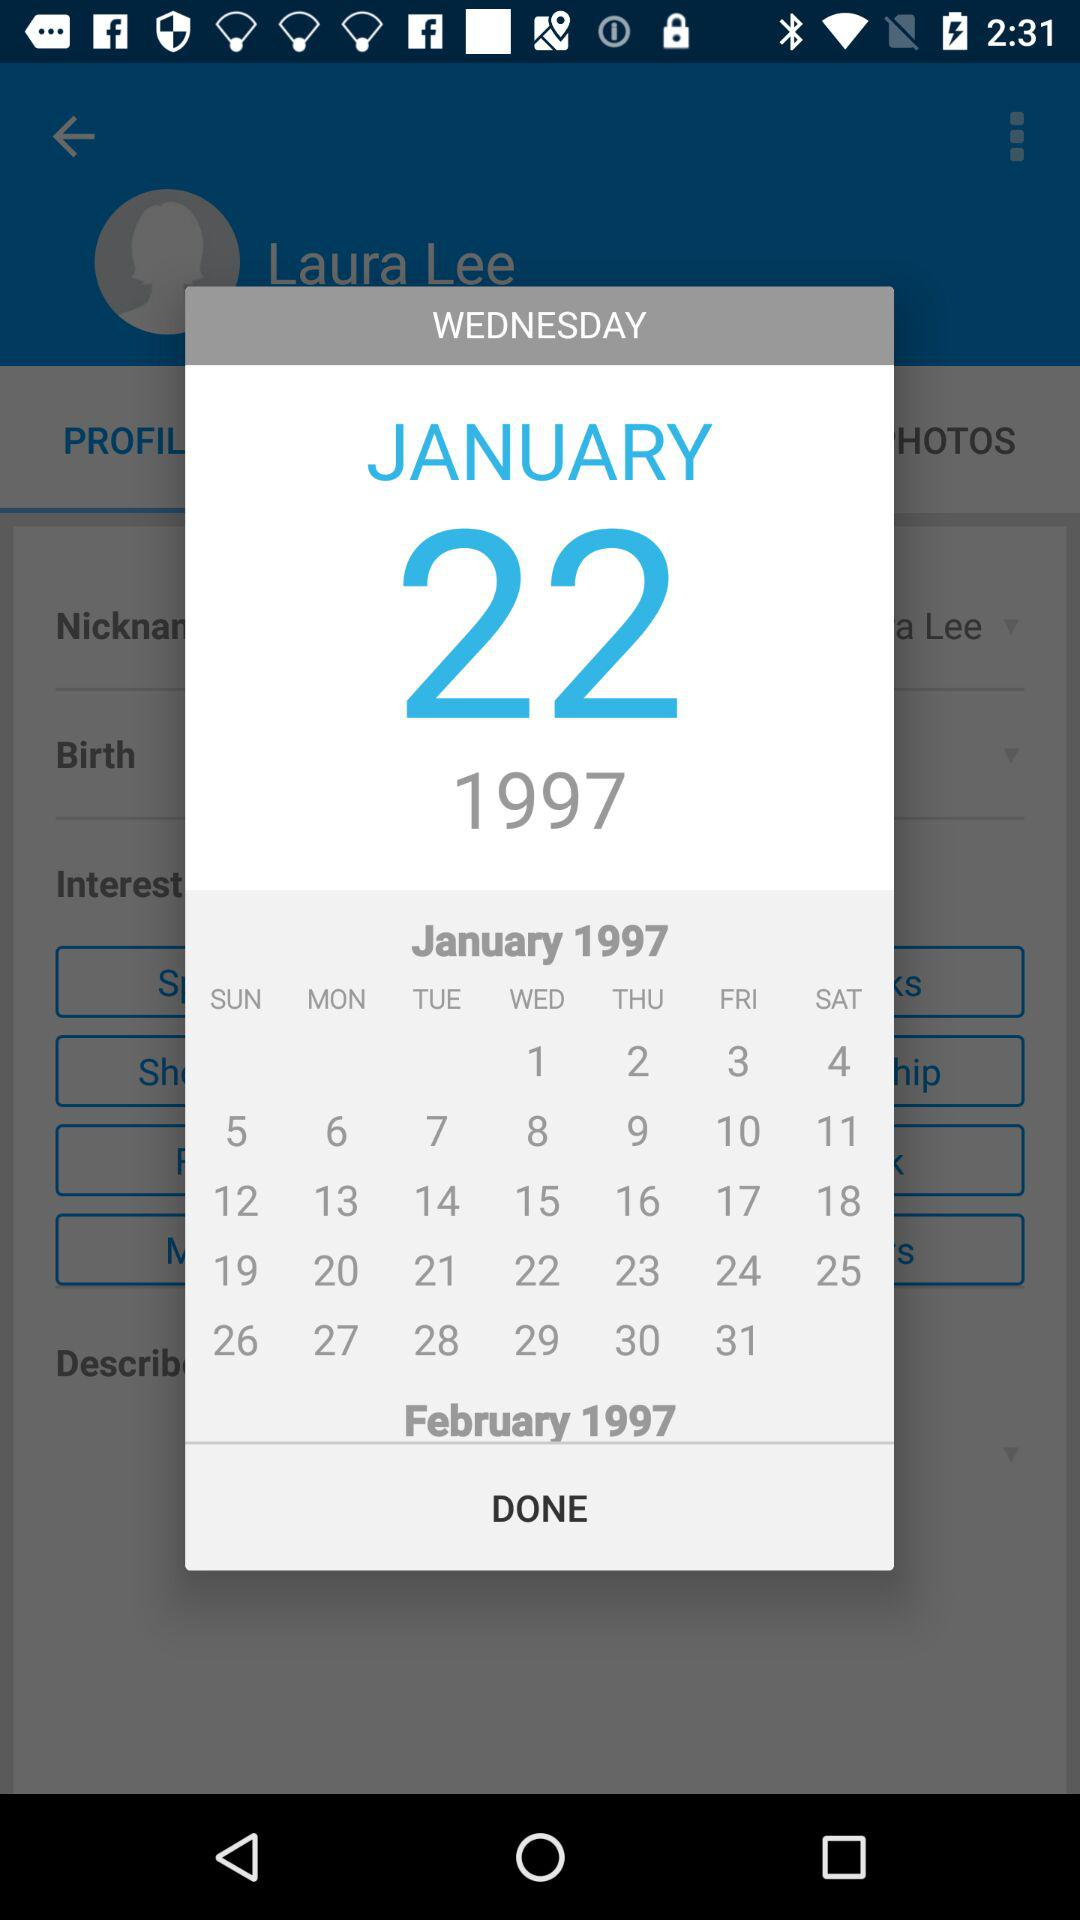What is the date selected in the calendar? The selected date is Wednesday, January 22, 1997. 